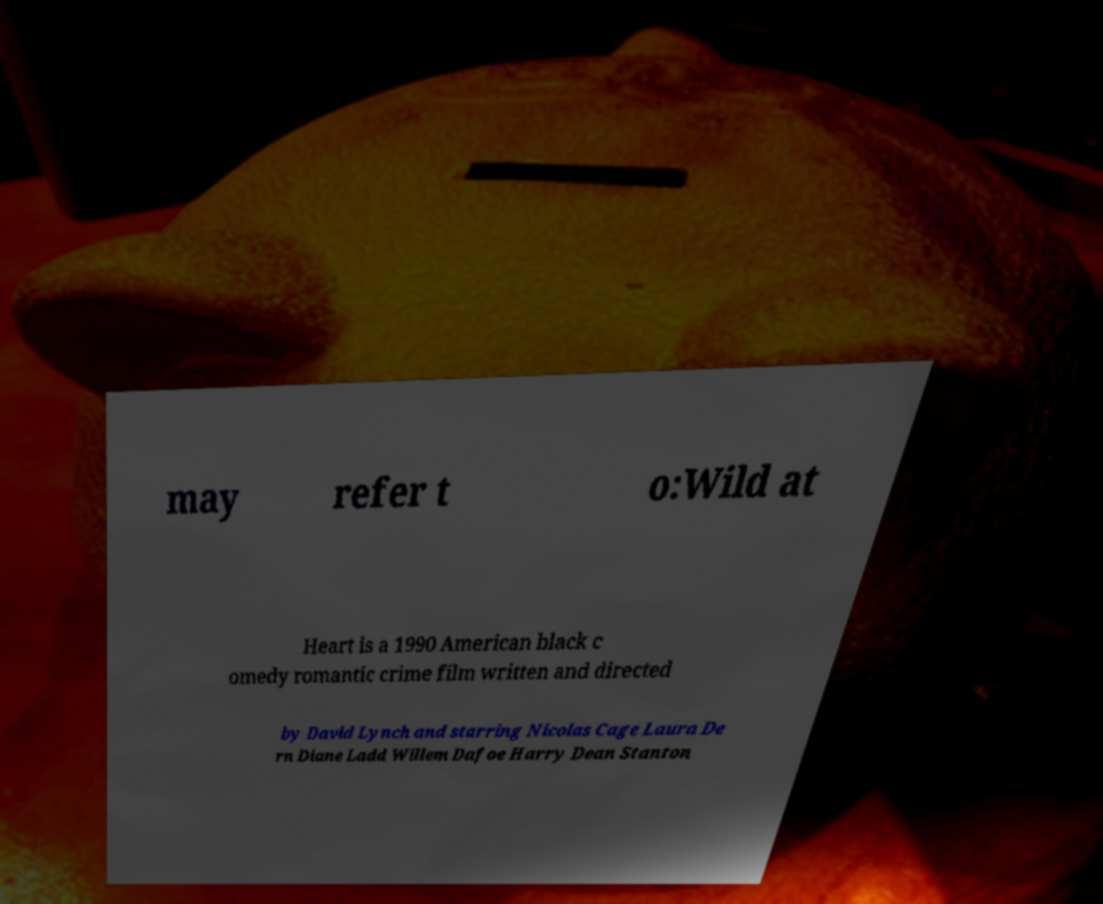What messages or text are displayed in this image? I need them in a readable, typed format. may refer t o:Wild at Heart is a 1990 American black c omedy romantic crime film written and directed by David Lynch and starring Nicolas Cage Laura De rn Diane Ladd Willem Dafoe Harry Dean Stanton 